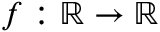Convert formula to latex. <formula><loc_0><loc_0><loc_500><loc_500>f \colon \mathbb { R } \rightarrow \mathbb { R }</formula> 